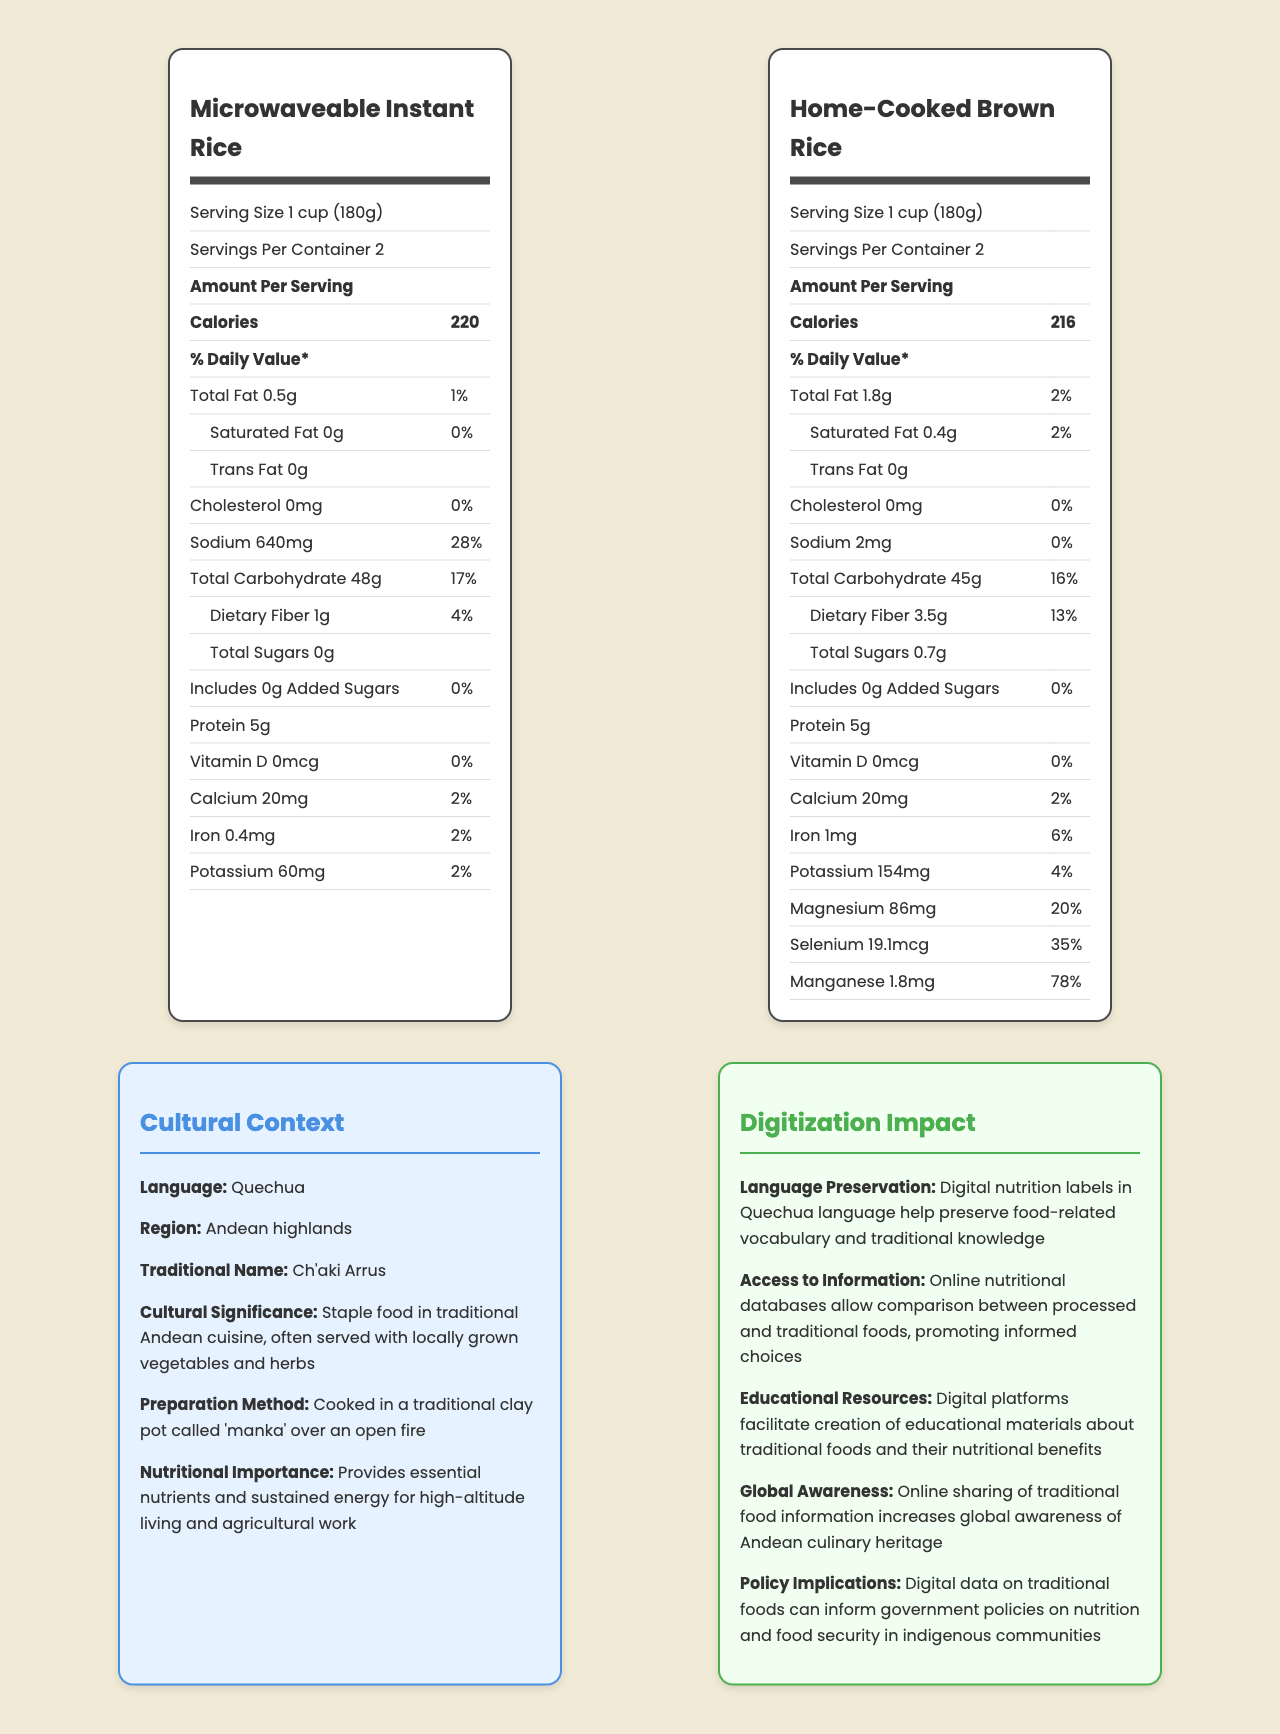what is the serving size of Microwaveable Instant Rice? The serving size is stated as "1 cup (180g)" in the nutrition label of Microwaveable Instant Rice.
Answer: 1 cup (180g) how many calories are in one serving of Home-Cooked Brown Rice? The calories per serving of Home-Cooked Brown Rice is 216, as indicated in its nutrition label.
Answer: 216 what percentage of the daily value is the sodium content in Microwaveable Instant Rice? The sodium content provides 28% of the daily value, according to the nutrition label of Microwaveable Instant Rice.
Answer: 28% how much dietary fiber does Home-Cooked Brown Rice contain per serving? The dietary fiber content per serving in Home-Cooked Brown Rice is 3.5g, as shown in its nutrition label.
Answer: 3.5g what are the cultural and regional associations of "Ch'aki Arrus"? The cultural context states that "Ch'aki Arrus" is associated with the Andean highlands and is a staple food in traditional Andean cuisine.
Answer: Andean highlands, staple food in traditional Andean cuisine compare the total carbohydrate content of Microwaveable Instant Rice and Home-Cooked Brown Rice. A. Both have the same B. Microwaveable Instant Rice has more C. Home-Cooked Brown Rice has more Microwaveable Instant Rice has 48g of total carbohydrates per serving, while Home-Cooked Brown Rice has 45g.
Answer: B. Microwaveable Instant Rice has more which has a higher percent daily value for iron? A. Microwaveable Instant Rice B. Home-Cooked Brown Rice Home-Cooked Brown Rice has a 6% daily value for iron while Microwaveable Instant Rice has a 2%.
Answer: B. Home-Cooked Brown Rice does Microwaveable Instant Rice contain any added sugars? The label indicates 0g of added sugars for Microwaveable Instant Rice.
Answer: No does the nutritional label for Home-Cooked Brown Rice list vitamin D content? The label specifies that there is 0mcg of Vitamin D in Home-Cooked Brown Rice.
Answer: Yes summarize the primary focus of the document. The document compares the nutritional facts of Microwaveable Instant Rice and Home-Cooked Brown Rice, discusses the cultural significance of traditional Andean food (Ch'aki Arrus), and outlines the impact of digital platforms on language preservation, educational resources, and policy-making.
Answer: Comparative nutritional assessments and cultural impact of traditional versus processed foods how is "Home-Cooked Brown Rice" traditionally prepared? The visual document does not provide specific details on how Home-Cooked Brown Rice is traditionally prepared.
Answer: Cannot be determined 